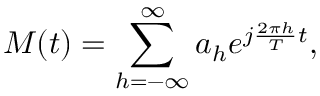Convert formula to latex. <formula><loc_0><loc_0><loc_500><loc_500>M ( t ) = \sum _ { h = - \infty } ^ { \infty } a _ { h } e ^ { j \frac { 2 \pi h } { T } t } ,</formula> 